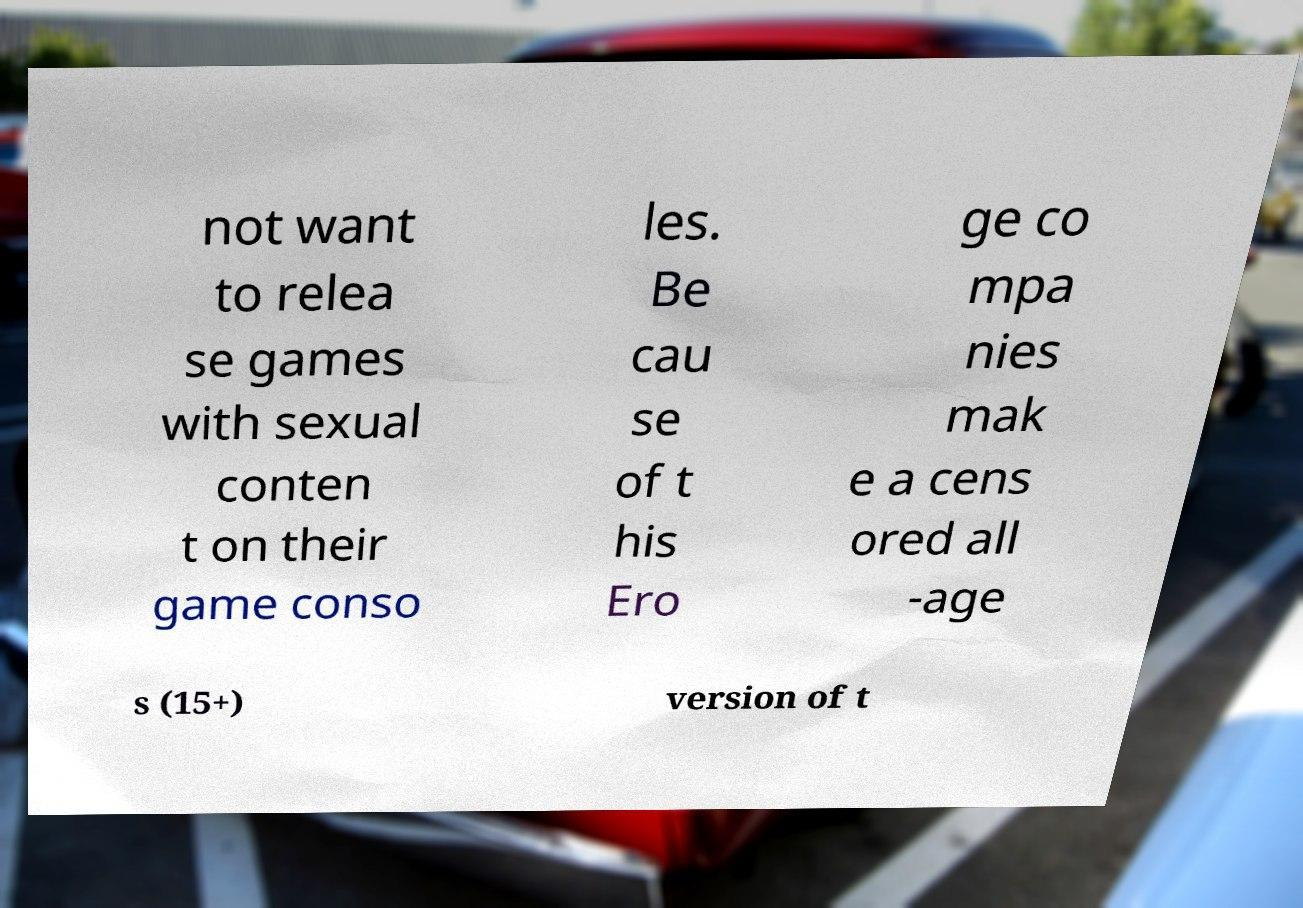What messages or text are displayed in this image? I need them in a readable, typed format. not want to relea se games with sexual conten t on their game conso les. Be cau se of t his Ero ge co mpa nies mak e a cens ored all -age s (15+) version of t 